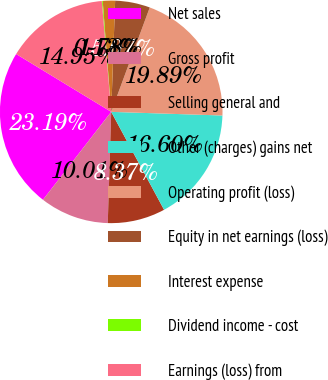<chart> <loc_0><loc_0><loc_500><loc_500><pie_chart><fcel>Net sales<fcel>Gross profit<fcel>Selling general and<fcel>Other (charges) gains net<fcel>Operating profit (loss)<fcel>Equity in net earnings (loss)<fcel>Interest expense<fcel>Dividend income - cost<fcel>Earnings (loss) from<nl><fcel>23.19%<fcel>10.01%<fcel>8.37%<fcel>16.6%<fcel>19.89%<fcel>5.07%<fcel>1.78%<fcel>0.13%<fcel>14.95%<nl></chart> 